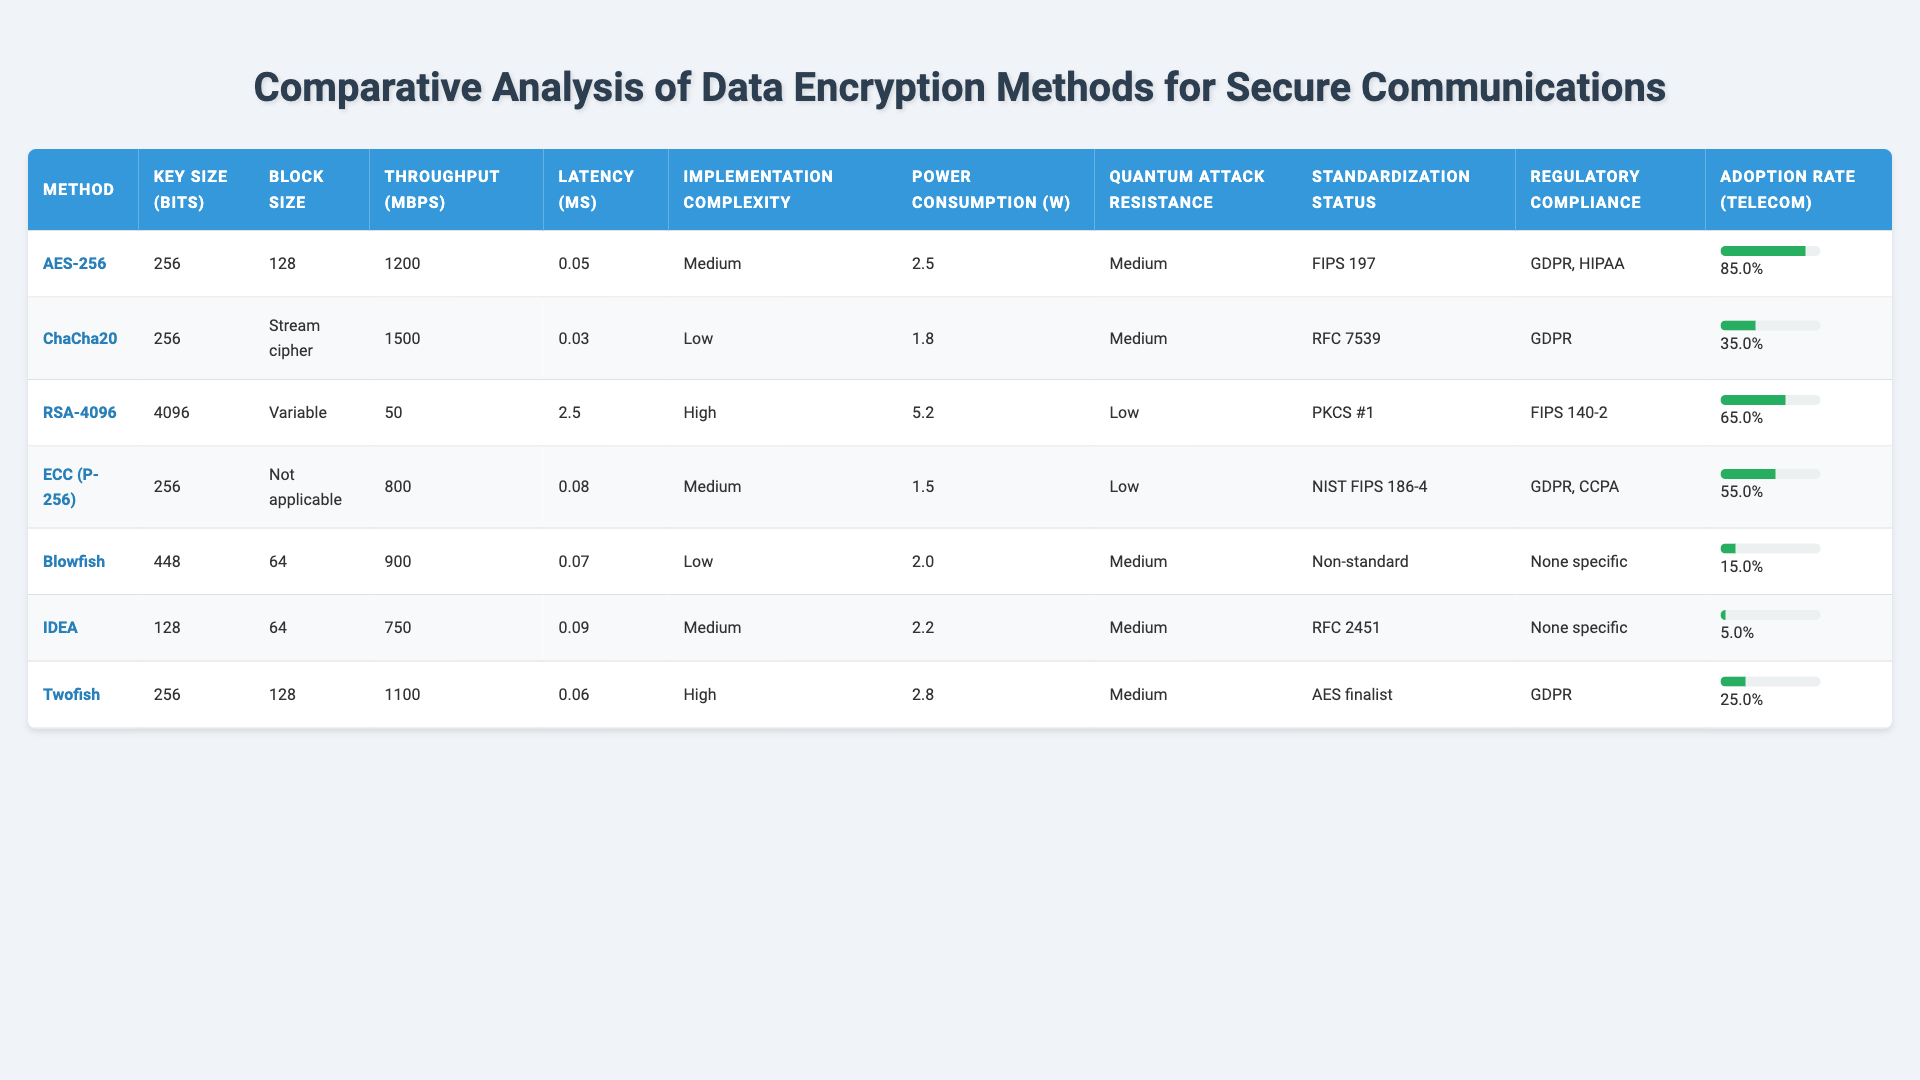What is the throughput of AES-256? The table shows that AES-256 has a throughput of 1200 Mbps listed under the "Throughput (Mbps)" column.
Answer: 1200 Mbps Which encryption method has the highest adoption rate in telecommunications? By comparing the adoption rates in the "Adoption Rate (Telecom)" column, ChaCha20 has the highest rate at 85%.
Answer: AES-256 What is the key size of RSA-4096? The table indicates that the key size for RSA-4096 is 4096 bits in the "Key Size (bits)" column.
Answer: 4096 bits What is the combined throughput of Twofish and Blowfish? The throughput for Twofish is 1100 Mbps and for Blowfish is 900 Mbps. Adding these together (1100 + 900) gives 2000 Mbps as the combined throughput.
Answer: 2000 Mbps Which method is the lowest in power consumption? The "Power Consumption (W)" column lists the power consumption for each method; ECC (P-256) has the lowest at 1.5 watts.
Answer: ECC (P-256) Is the resistance to quantum attacks for RSA-4096 high? The table classifies RSA-4096 as having "Low" resistance to quantum attacks according to its "Resistance to Quantum Attacks" column.
Answer: No What is the average latency of all methods listed? To find the average latency, sum the latencies (0.05 + 0.03 + 2.5 + 0.08 + 0.07 + 0.09 + 0.06) which equals 2.88 ms; there are 7 methods, so the average is 2.88 / 7 = approximately 0.4 ms.
Answer: 0.4 ms Which encryption method has the highest key size? Looking at the "Key Size (bits)" column, RSA-4096 has the highest key size at 4096 bits.
Answer: RSA-4096 What is the standardization status of Blowfish? The table lists Blowfish’s standardization status as "Non-standard" in the "Standardization Status" column.
Answer: Non-standard How many methods have a power consumption below 2 watts? By examining the "Power Consumption (W)" column, the methods with power consumption below 2 watts are ChaCha20 (1.8), ECC (P-256) (1.5), and Blowfish (2.0), totaling 3 methods.
Answer: 3 